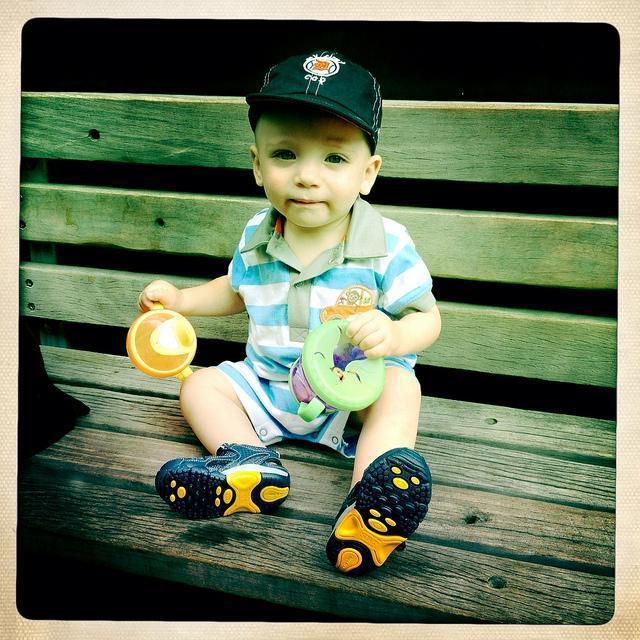How many cups is the baby holding?
Give a very brief answer. 2. How many cups are in the picture?
Give a very brief answer. 2. 